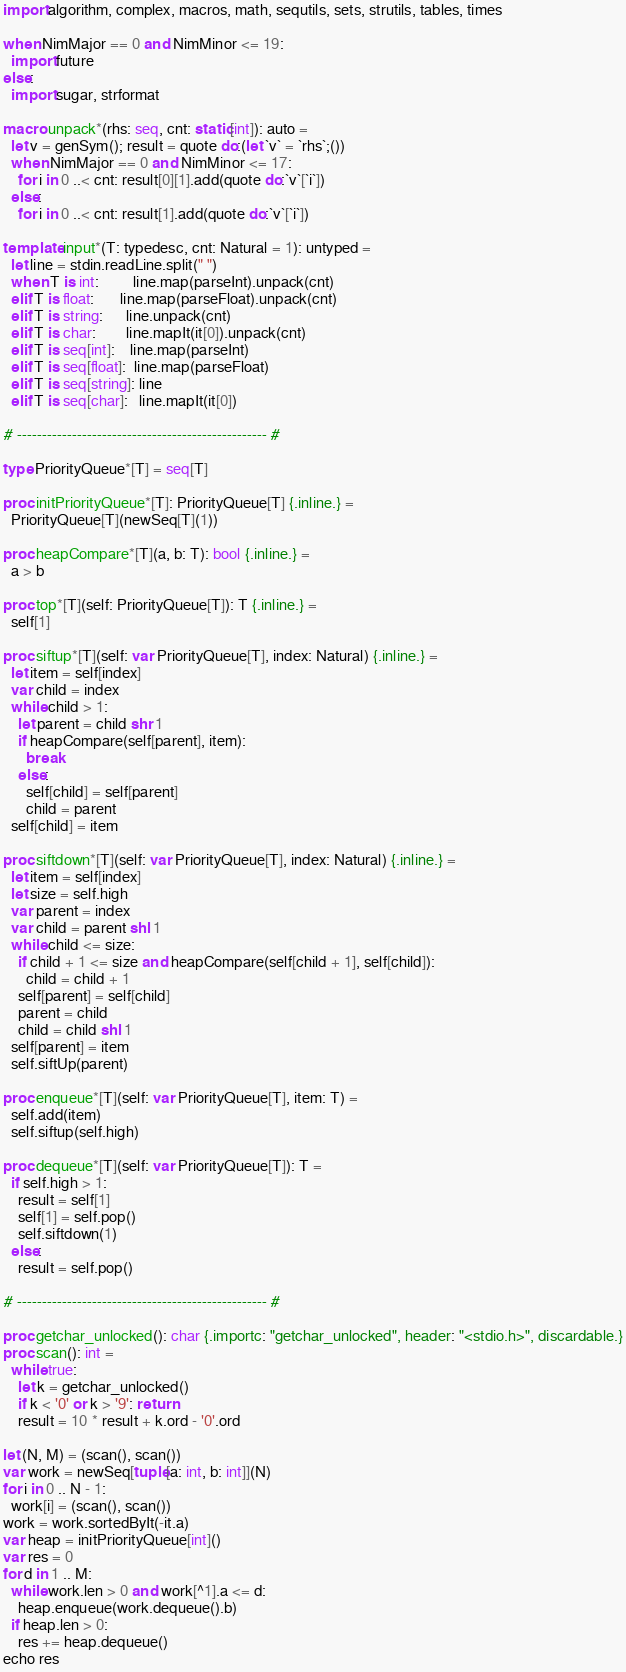<code> <loc_0><loc_0><loc_500><loc_500><_Nim_>import algorithm, complex, macros, math, sequtils, sets, strutils, tables, times

when NimMajor == 0 and NimMinor <= 19:
  import future
else:
  import sugar, strformat

macro unpack*(rhs: seq, cnt: static[int]): auto =
  let v = genSym(); result = quote do:(let `v` = `rhs`;())
  when NimMajor == 0 and NimMinor <= 17:
    for i in 0 ..< cnt: result[0][1].add(quote do:`v`[`i`])
  else:
    for i in 0 ..< cnt: result[1].add(quote do:`v`[`i`])

template input*(T: typedesc, cnt: Natural = 1): untyped =
  let line = stdin.readLine.split(" ")
  when T is int:         line.map(parseInt).unpack(cnt)
  elif T is float:       line.map(parseFloat).unpack(cnt)
  elif T is string:      line.unpack(cnt)
  elif T is char:        line.mapIt(it[0]).unpack(cnt)
  elif T is seq[int]:    line.map(parseInt)
  elif T is seq[float]:  line.map(parseFloat)
  elif T is seq[string]: line
  elif T is seq[char]:   line.mapIt(it[0])

# -------------------------------------------------- #

type PriorityQueue*[T] = seq[T]
 
proc initPriorityQueue*[T]: PriorityQueue[T] {.inline.} =
  PriorityQueue[T](newSeq[T](1))

proc heapCompare*[T](a, b: T): bool {.inline.} =
  a > b
 
proc top*[T](self: PriorityQueue[T]): T {.inline.} =
  self[1]
 
proc siftup*[T](self: var PriorityQueue[T], index: Natural) {.inline.} =
  let item = self[index]
  var child = index
  while child > 1:
    let parent = child shr 1
    if heapCompare(self[parent], item):
      break
    else:
      self[child] = self[parent]
      child = parent
  self[child] = item
 
proc siftdown*[T](self: var PriorityQueue[T], index: Natural) {.inline.} =
  let item = self[index]
  let size = self.high
  var parent = index
  var child = parent shl 1
  while child <= size:
    if child + 1 <= size and heapCompare(self[child + 1], self[child]):
      child = child + 1
    self[parent] = self[child]
    parent = child
    child = child shl 1
  self[parent] = item
  self.siftUp(parent)
 
proc enqueue*[T](self: var PriorityQueue[T], item: T) =
  self.add(item)
  self.siftup(self.high)
 
proc dequeue*[T](self: var PriorityQueue[T]): T =
  if self.high > 1:
    result = self[1]
    self[1] = self.pop()
    self.siftdown(1)
  else:
    result = self.pop()
 
# -------------------------------------------------- #

proc getchar_unlocked(): char {.importc: "getchar_unlocked", header: "<stdio.h>", discardable.}
proc scan(): int =
  while true:
    let k = getchar_unlocked()
    if k < '0' or k > '9': return
    result = 10 * result + k.ord - '0'.ord
 
let (N, M) = (scan(), scan())
var work = newSeq[tuple[a: int, b: int]](N)
for i in 0 .. N - 1:
  work[i] = (scan(), scan())
work = work.sortedByIt(-it.a)
var heap = initPriorityQueue[int]()
var res = 0
for d in 1 .. M:
  while work.len > 0 and work[^1].a <= d:
    heap.enqueue(work.dequeue().b)
  if heap.len > 0:
    res += heap.dequeue()
echo res</code> 